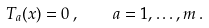Convert formula to latex. <formula><loc_0><loc_0><loc_500><loc_500>T _ { a } ( x ) = 0 \, , \quad a = 1 , \dots , m \, .</formula> 